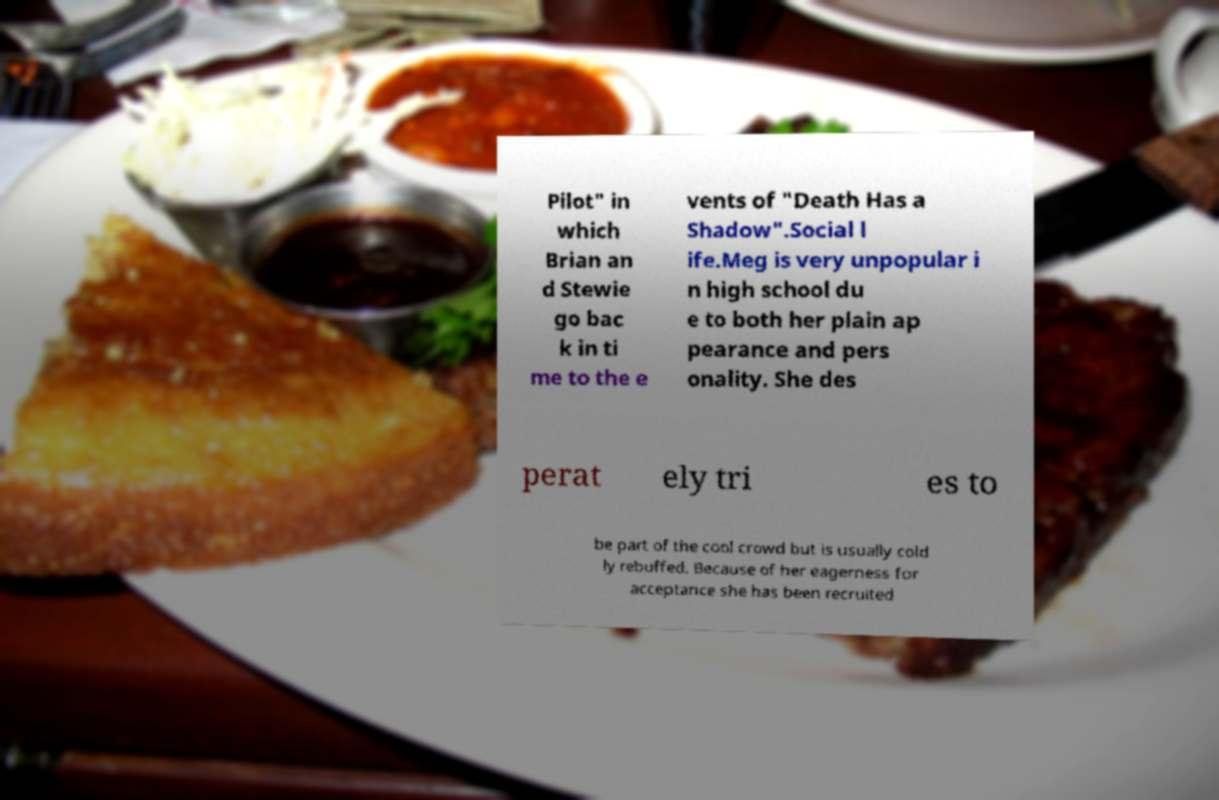What messages or text are displayed in this image? I need them in a readable, typed format. Pilot" in which Brian an d Stewie go bac k in ti me to the e vents of "Death Has a Shadow".Social l ife.Meg is very unpopular i n high school du e to both her plain ap pearance and pers onality. She des perat ely tri es to be part of the cool crowd but is usually cold ly rebuffed. Because of her eagerness for acceptance she has been recruited 